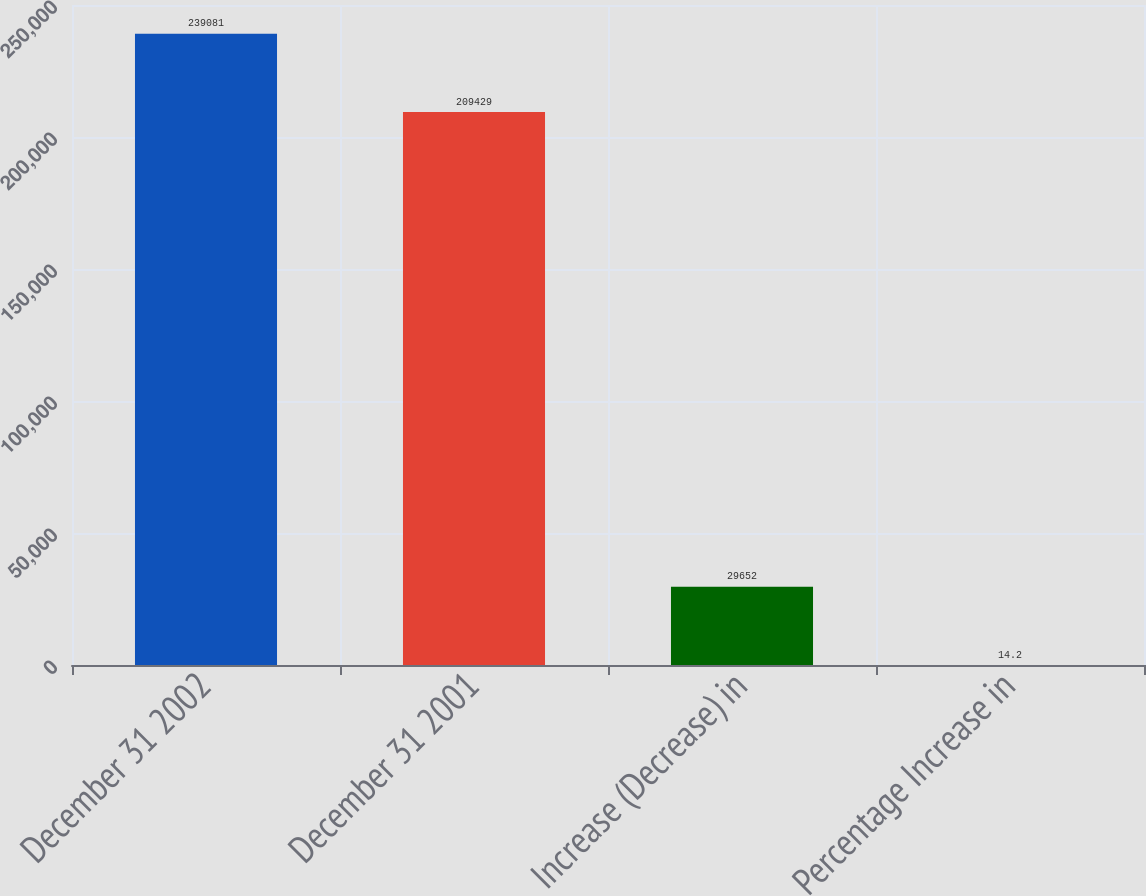Convert chart to OTSL. <chart><loc_0><loc_0><loc_500><loc_500><bar_chart><fcel>December 31 2002<fcel>December 31 2001<fcel>Increase (Decrease) in<fcel>Percentage Increase in<nl><fcel>239081<fcel>209429<fcel>29652<fcel>14.2<nl></chart> 